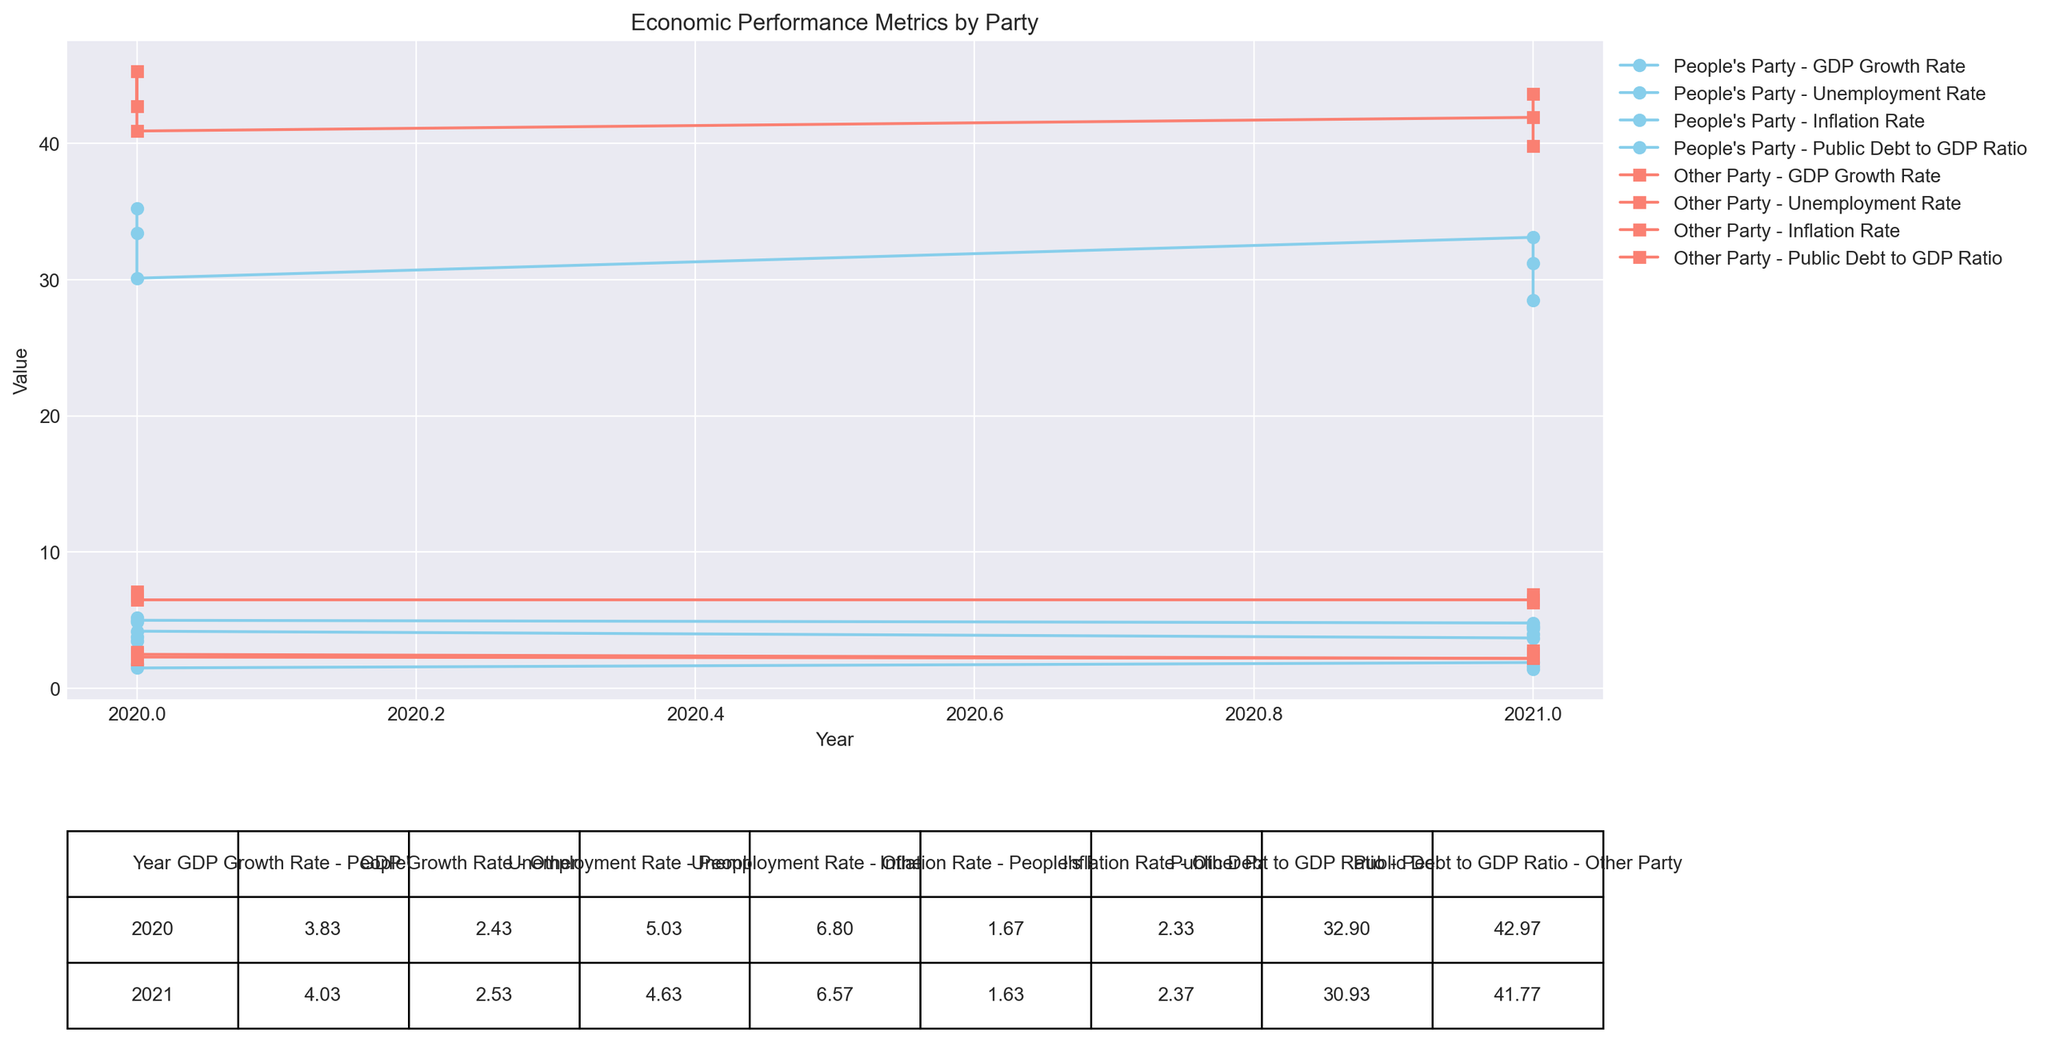What is the average GDP growth rate in regions governed by the People's Party in 2020? First, we identify the regions governed by the People's Party in 2020: Region A, Region C, and Region E. Their GDP growth rates are 3.5%, 3.8%, and 4.2% respectively. Summing these rates gives 3.5 + 3.8 + 4.2 = 11.5. Dividing by the number of regions (3) gives 11.5 / 3 = 3.83.
Answer: 3.83% How did the unemployment rate in regions governed by the People's Party change from 2020 to 2021? We find the unemployment rates for 2020 and 2021 in regions governed by the People's Party. For 2020, the rates are 5.2%, 4.9%, and 5.0%, which average to (5.2 + 4.9 + 5.0)/3 = 5.03%. For 2021, the rates are 4.8%, 4.5%, and 4.6%, averaging (4.8 + 4.5 + 4.6)/3 = 4.63%. The change is 5.03% - 4.63% = 0.40%.
Answer: Decreased by 0.40% Which party's regions had a higher inflation rate in 2021? Comparing the average inflation rates for 2021: People's Party regions (1.9%, 1.6%, 1.4%) average to (1.9 + 1.6 + 1.4) / 3 = 1.63%. Other regions (2.2%, 2.4%, 2.5%) average to (2.2 + 2.4 + 2.5) / 3 = 2.37%.
Answer: Other Party Which party's regions experienced a higher GDP growth rate on average in 2021? We compare the GDP growth rates for 2021: People's Party regions (3.7%, 4.0%, 4.4%) average to (3.7 + 4.0 + 4.4) / 3 = 4.03%. Other regions (2.2%, 2.8%, 2.6%) average to (2.2 + 2.8 + 2.6) / 3 = 2.53%.
Answer: People's Party What is the difference in the average public debt to GDP ratio between People's Party and Other Party regions in 2020? We calculate the average public debt to GDP ratios for 2020: People's Party regions (35.2%, 33.4%, 30.1%) average to (35.2 + 33.4 + 30.1) / 3 = 32.9%. Other Party regions (42.7%, 45.3%, 40.9%) average to (42.7 + 45.3 + 40.9) / 3 = 42.97%. The difference is 42.97% - 32.9% = 10.07%.
Answer: 10.07% What visual patterns can you observe between regions governed by the People's Party and Other Party from the figure? Observing the plotted lines, regions governed by the People's Party generally show lower unemployment and inflation rates, higher GDP growth rates, and lower public debt to GDP ratios compared to Other Party regions.
Answer: Lower unemployment & inflation, higher GDP growth, lower public debt for People's Party In which year did regions governed by the People's Party have the lowest average inflation rate? Reviewing the data, the average inflation rates for People's Party regions in 2020 and 2021 are 1.83% and 1.63%, respectively. Hence, 2021 has the lowest average inflation rate.
Answer: 2021 Which metric saw the biggest improvement from 2020 to 2021 in regions governed by the People's Party? We compare changes in average metrics: GDP Growth Rate increased from 3.83% to 4.03%, Unemployment Rate decreased from 5.03% to 4.63%, Inflation Rate slightly increased from 1.83% to 1.63%, and Public Debt to GDP Ratio decreased from 32.9% to 31.6%. The biggest improvement is the decrease in the Unemployment Rate.
Answer: Unemployment Rate Which year had the higher average GDP growth rate for regions governed by both parties combined? Calculating the average: 2020 rates are 3.5, 2.1, 3.8, 2.7, 4.2, 2.5, averaging (3.5 + 2.1 + 3.8 + 2.7 + 4.2 + 2.5) / 6 = 3.13%. 2021 rates are 3.7, 2.2, 4.0, 2.8, 4.4, 2.6, averaging (3.7 + 2.2 + 4.0 + 2.8 + 4.4 + 2.6) / 6 = 3.28%.
Answer: 2021 Which party's regions had the lowest average unemployment rate in 2021? The average unemployment rates for 2021 are 4.63% for People's Party regions and 6.57% for Other Party regions. Hence, People's Party regions have the lowest average unemployment rate.
Answer: People's Party 